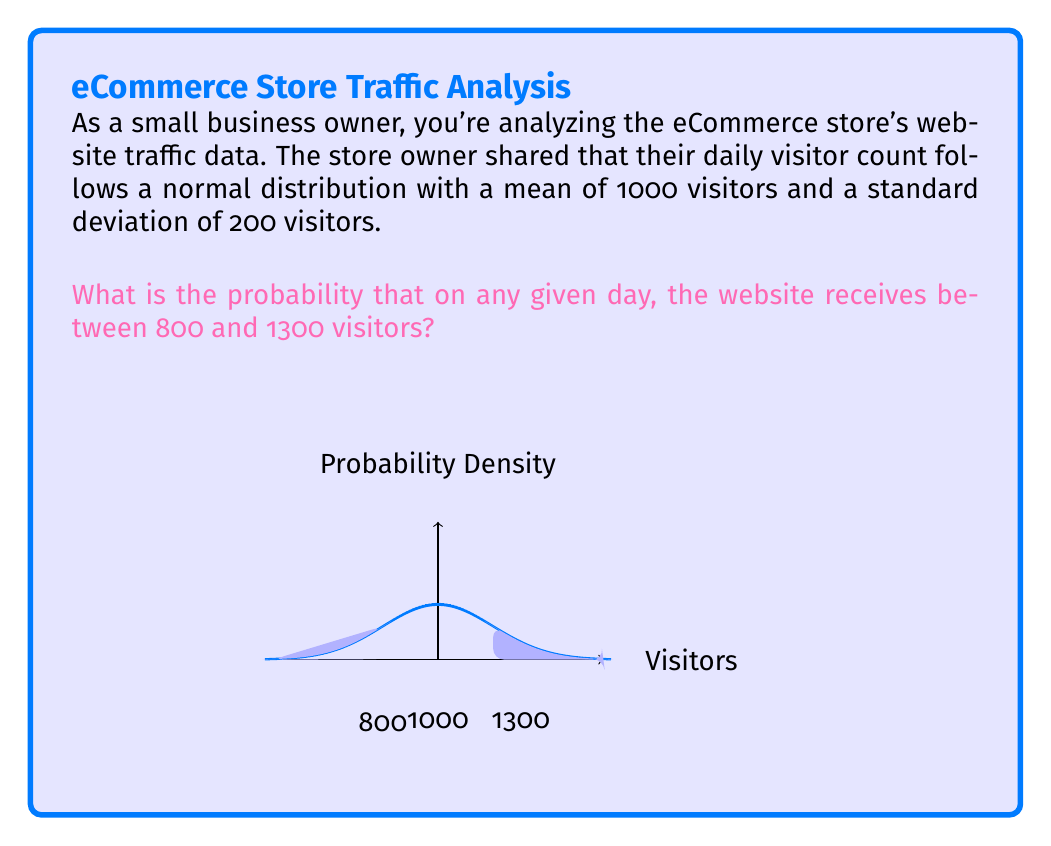What is the answer to this math problem? To solve this problem, we'll use the properties of the normal distribution and the concept of z-scores. Here's a step-by-step approach:

1) First, we need to calculate the z-scores for both 800 and 1300 visitors.
   The z-score formula is: $z = \frac{x - \mu}{\sigma}$
   Where $x$ is the value, $\mu$ is the mean, and $\sigma$ is the standard deviation.

2) For 800 visitors:
   $z_1 = \frac{800 - 1000}{200} = -1$

3) For 1300 visitors:
   $z_2 = \frac{1300 - 1000}{200} = 1.5$

4) Now, we need to find the area under the standard normal curve between these two z-scores.
   This can be done using a standard normal table or a calculator with a built-in function.

5) The probability is equal to:
   $P(-1 < Z < 1.5) = P(Z < 1.5) - P(Z < -1)$

6) Using a standard normal table or calculator:
   $P(Z < 1.5) \approx 0.9332$
   $P(Z < -1) \approx 0.1587$

7) Therefore, the probability is:
   $0.9332 - 0.1587 = 0.7745$

This means there's approximately a 77.45% chance that the website receives between 800 and 1300 visitors on any given day.
Answer: $$0.7745 \text{ or } 77.45\%$$ 